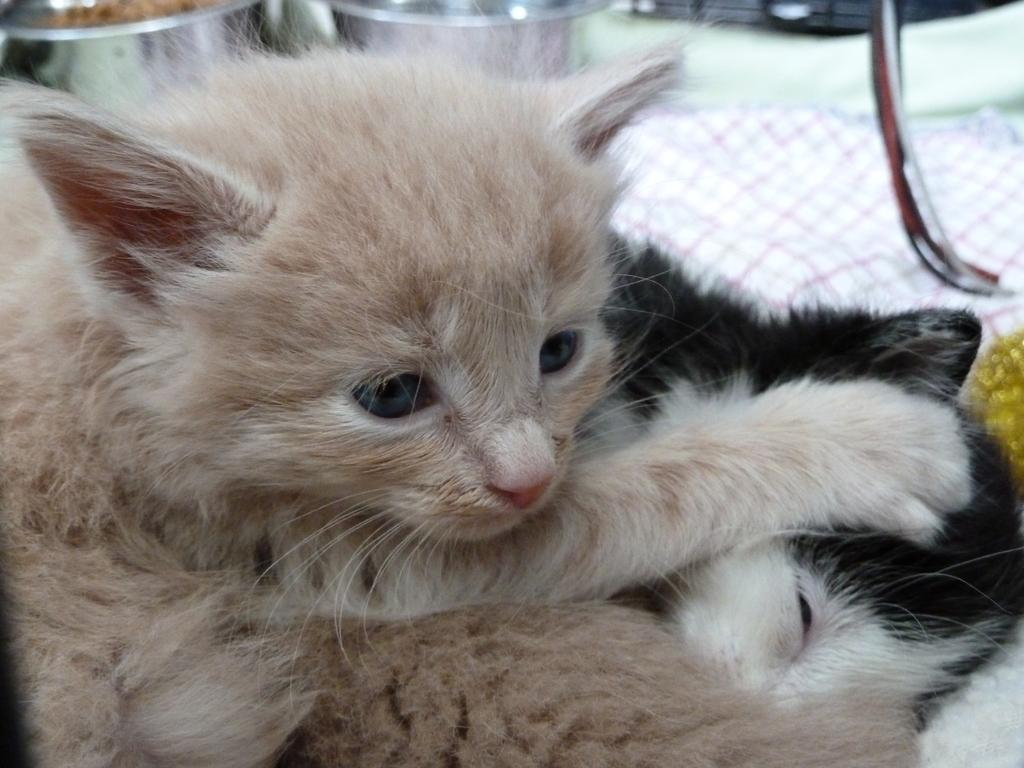What is the main subject in the center of the image? There is a cat in the center of the image. What can be seen in the background of the image? There are two utensils in the background of the image. What other animal is present in the image? There is another animal at the bottom of the image. How does the cat stretch in the image? The image does not show the cat stretching; it is simply sitting in the center of the image. 